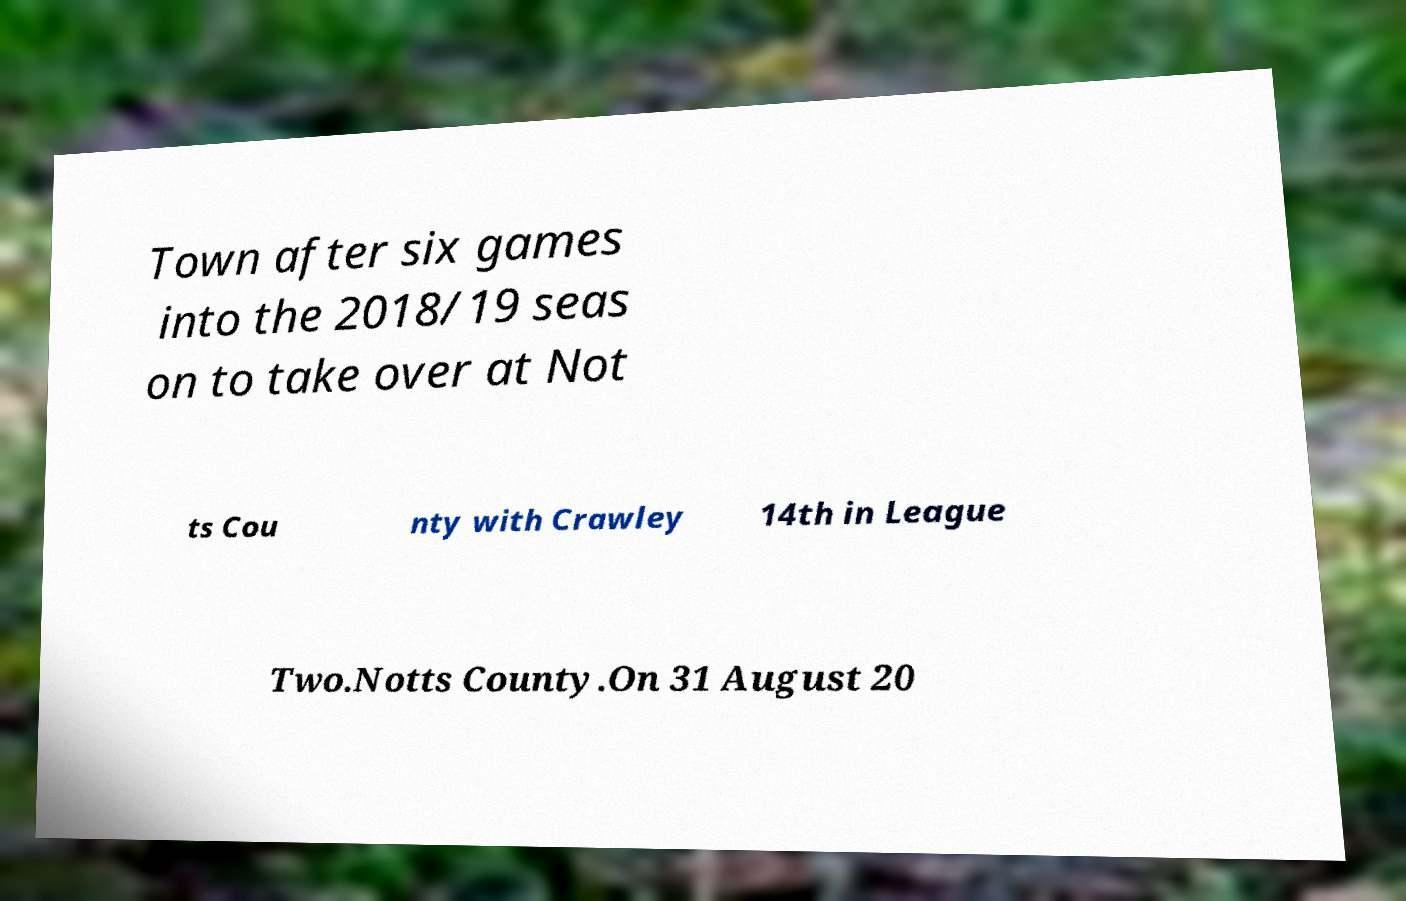Can you read and provide the text displayed in the image?This photo seems to have some interesting text. Can you extract and type it out for me? Town after six games into the 2018/19 seas on to take over at Not ts Cou nty with Crawley 14th in League Two.Notts County.On 31 August 20 